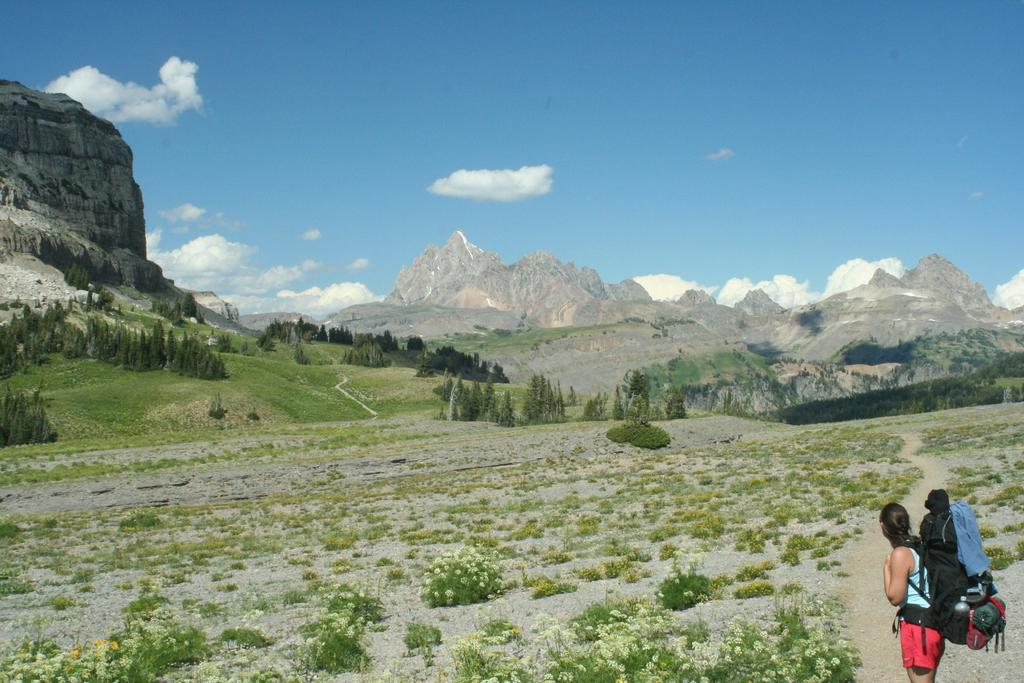What is the main subject of the image? There is a woman standing in the image. What is the woman carrying in the image? The woman is carrying a bag. What type of vegetation can be seen in the image? There are plants, flowers, trees, and grass visible in the image. What is visible in the background of the image? There are hills, trees, grass, and the sky visible in the background of the image. What can be seen in the sky in the image? There are clouds in the sky. What type of baseball game is taking place in the image? There is no baseball game present in the image. Can you tell me where the quartz can be found in the image? There is no quartz present in the image. 